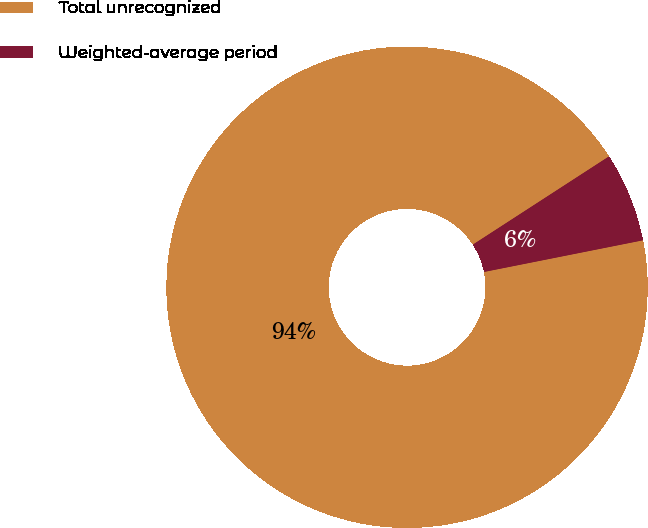<chart> <loc_0><loc_0><loc_500><loc_500><pie_chart><fcel>Total unrecognized<fcel>Weighted-average period<nl><fcel>93.98%<fcel>6.02%<nl></chart> 